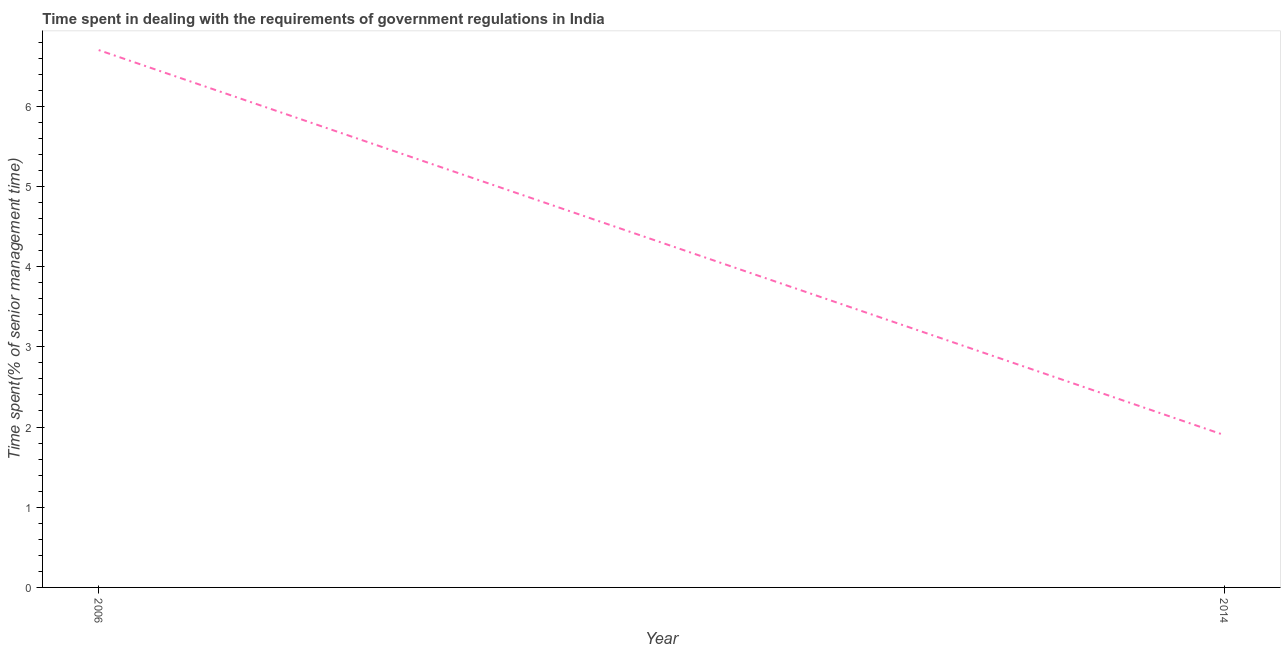Across all years, what is the maximum time spent in dealing with government regulations?
Provide a succinct answer. 6.7. In which year was the time spent in dealing with government regulations maximum?
Offer a very short reply. 2006. What is the difference between the time spent in dealing with government regulations in 2006 and 2014?
Provide a succinct answer. 4.8. What is the median time spent in dealing with government regulations?
Offer a very short reply. 4.3. In how many years, is the time spent in dealing with government regulations greater than 5.8 %?
Make the answer very short. 1. Do a majority of the years between 2006 and 2014 (inclusive) have time spent in dealing with government regulations greater than 3.2 %?
Make the answer very short. No. What is the ratio of the time spent in dealing with government regulations in 2006 to that in 2014?
Give a very brief answer. 3.53. Is the time spent in dealing with government regulations in 2006 less than that in 2014?
Your answer should be compact. No. How many lines are there?
Your answer should be compact. 1. How many years are there in the graph?
Make the answer very short. 2. What is the difference between two consecutive major ticks on the Y-axis?
Your answer should be compact. 1. Are the values on the major ticks of Y-axis written in scientific E-notation?
Keep it short and to the point. No. Does the graph contain any zero values?
Offer a terse response. No. What is the title of the graph?
Offer a terse response. Time spent in dealing with the requirements of government regulations in India. What is the label or title of the Y-axis?
Ensure brevity in your answer.  Time spent(% of senior management time). What is the Time spent(% of senior management time) of 2006?
Ensure brevity in your answer.  6.7. What is the Time spent(% of senior management time) in 2014?
Keep it short and to the point. 1.9. What is the difference between the Time spent(% of senior management time) in 2006 and 2014?
Ensure brevity in your answer.  4.8. What is the ratio of the Time spent(% of senior management time) in 2006 to that in 2014?
Keep it short and to the point. 3.53. 